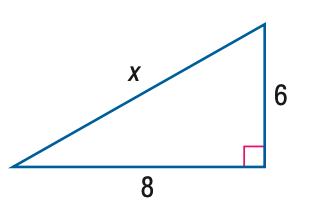Question: Find x.
Choices:
A. 5.3
B. 6
C. 8
D. 10
Answer with the letter. Answer: D 